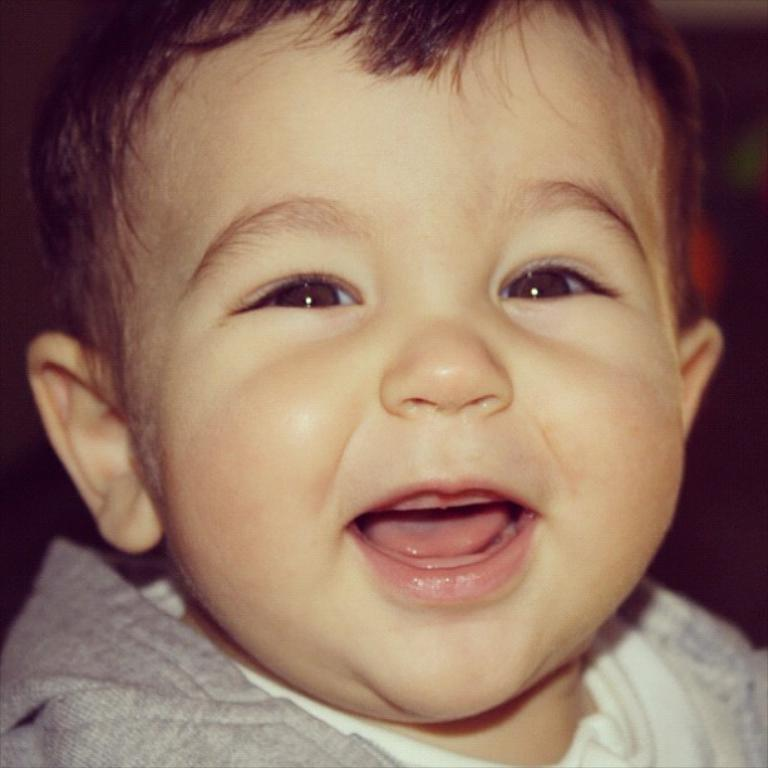What is the main subject of the picture? The main subject of the picture is a baby. What is the baby doing in the picture? The baby is smiling in the picture. What is the baby wearing in the picture? The baby is wearing a gray color T-shirt. What type of dogs can be seen playing with the baby in the picture? There are no dogs present in the image; it only features a baby. What is the baby drinking in the picture? The provided facts do not mention any drinks, such as eggnog, in the image. 